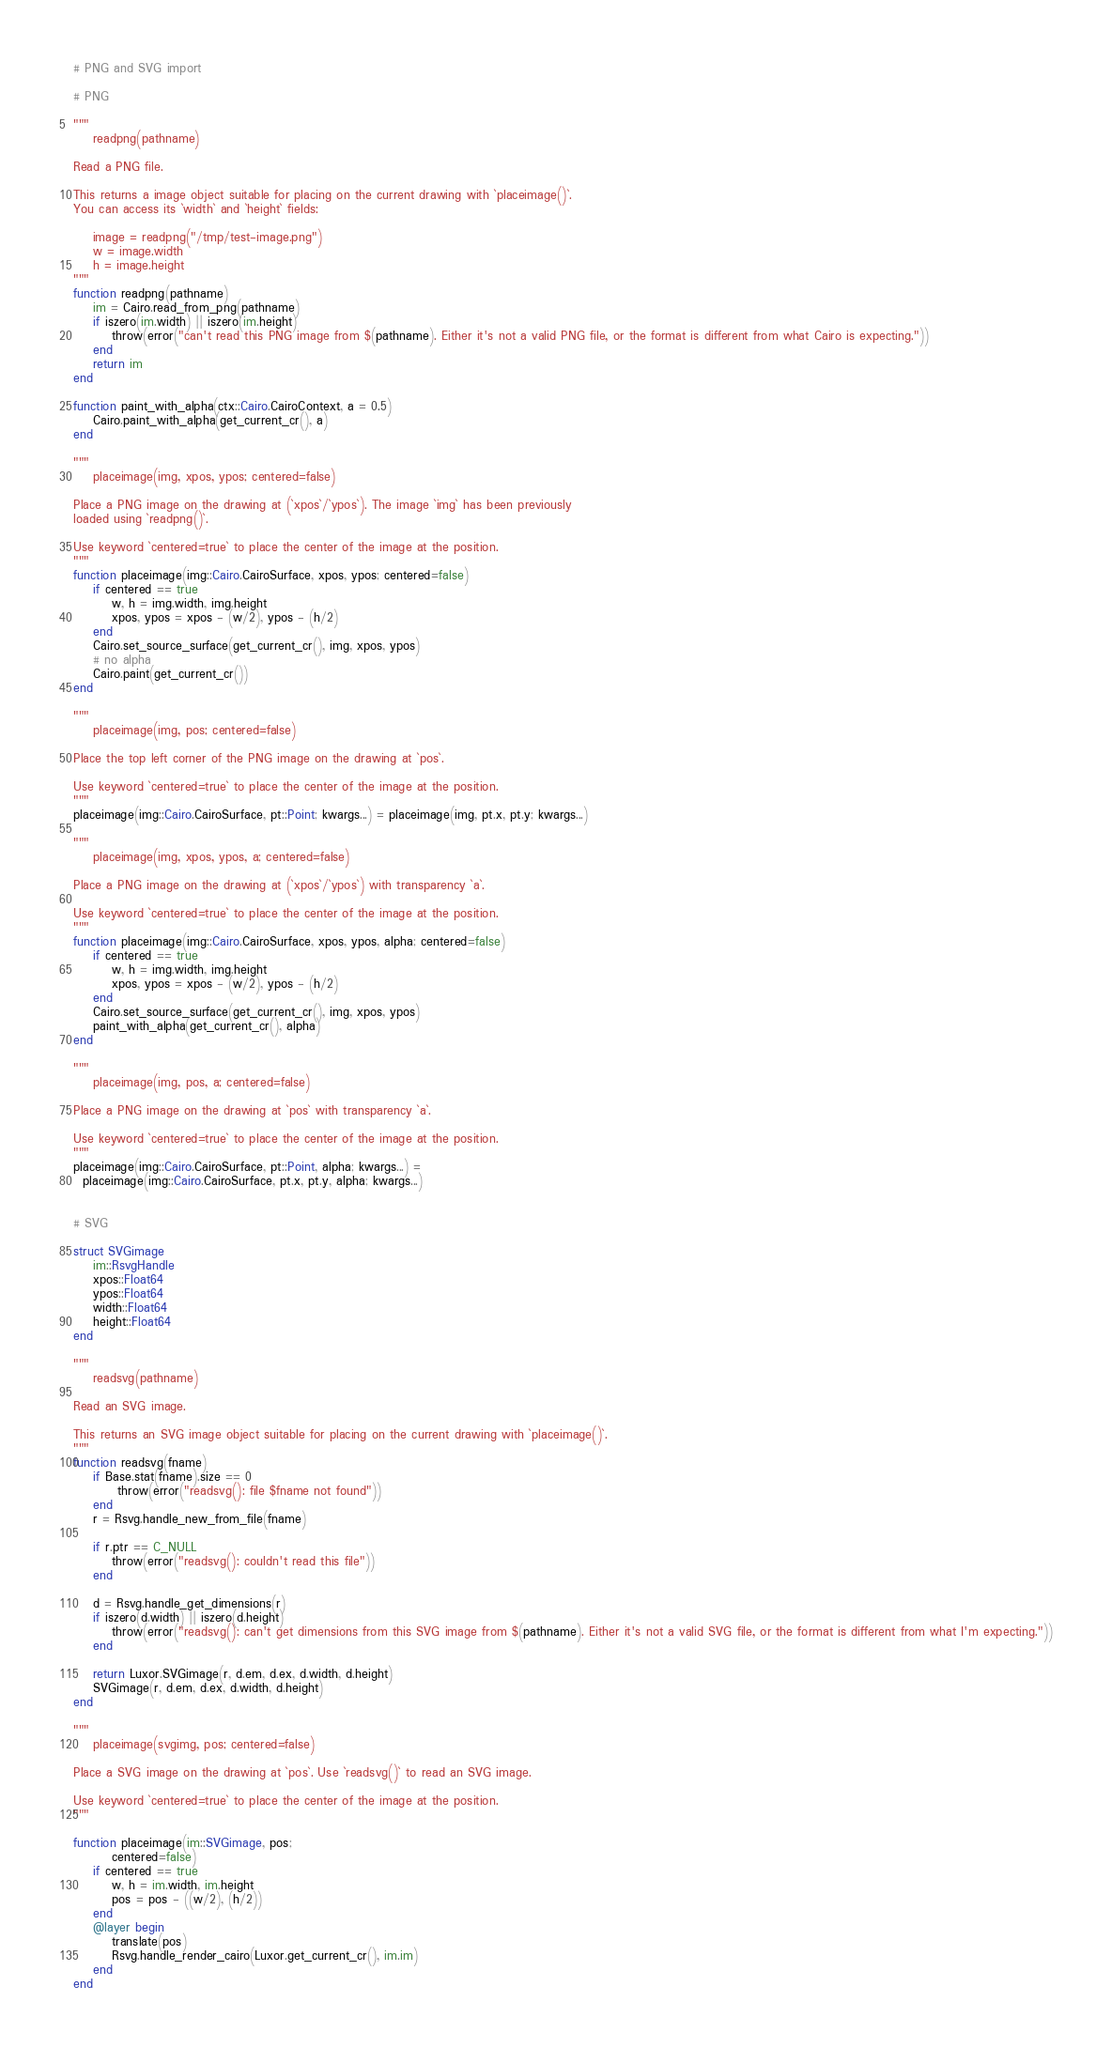Convert code to text. <code><loc_0><loc_0><loc_500><loc_500><_Julia_># PNG and SVG import

# PNG

"""
    readpng(pathname)

Read a PNG file.

This returns a image object suitable for placing on the current drawing with `placeimage()`.
You can access its `width` and `height` fields:

    image = readpng("/tmp/test-image.png")
    w = image.width
    h = image.height
"""
function readpng(pathname)
    im = Cairo.read_from_png(pathname)
    if iszero(im.width) || iszero(im.height)
        throw(error("can't read this PNG image from $(pathname). Either it's not a valid PNG file, or the format is different from what Cairo is expecting."))
    end
    return im
end

function paint_with_alpha(ctx::Cairo.CairoContext, a = 0.5)
    Cairo.paint_with_alpha(get_current_cr(), a)
end

"""
    placeimage(img, xpos, ypos; centered=false)

Place a PNG image on the drawing at (`xpos`/`ypos`). The image `img` has been previously
loaded using `readpng()`.

Use keyword `centered=true` to place the center of the image at the position.
"""
function placeimage(img::Cairo.CairoSurface, xpos, ypos; centered=false)
    if centered == true
        w, h = img.width, img.height
        xpos, ypos = xpos - (w/2), ypos - (h/2)
    end
    Cairo.set_source_surface(get_current_cr(), img, xpos, ypos)
    # no alpha
    Cairo.paint(get_current_cr())
end

"""
    placeimage(img, pos; centered=false)

Place the top left corner of the PNG image on the drawing at `pos`.

Use keyword `centered=true` to place the center of the image at the position.
"""
placeimage(img::Cairo.CairoSurface, pt::Point; kwargs...) = placeimage(img, pt.x, pt.y; kwargs...)

"""
    placeimage(img, xpos, ypos, a; centered=false)

Place a PNG image on the drawing at (`xpos`/`ypos`) with transparency `a`.

Use keyword `centered=true` to place the center of the image at the position.
"""
function placeimage(img::Cairo.CairoSurface, xpos, ypos, alpha; centered=false)
    if centered == true
        w, h = img.width, img.height
        xpos, ypos = xpos - (w/2), ypos - (h/2)
    end
    Cairo.set_source_surface(get_current_cr(), img, xpos, ypos)
    paint_with_alpha(get_current_cr(), alpha)
end

"""
    placeimage(img, pos, a; centered=false)

Place a PNG image on the drawing at `pos` with transparency `a`.

Use keyword `centered=true` to place the center of the image at the position.
"""
placeimage(img::Cairo.CairoSurface, pt::Point, alpha; kwargs...) =
  placeimage(img::Cairo.CairoSurface, pt.x, pt.y, alpha; kwargs...)


# SVG

struct SVGimage
    im::RsvgHandle
    xpos::Float64
    ypos::Float64
    width::Float64
    height::Float64
end

"""
    readsvg(pathname)

Read an SVG image.

This returns an SVG image object suitable for placing on the current drawing with `placeimage()`.
"""
function readsvg(fname)
    if Base.stat(fname).size == 0
         throw(error("readsvg(): file $fname not found"))
    end
    r = Rsvg.handle_new_from_file(fname)

    if r.ptr == C_NULL
        throw(error("readsvg(): couldn't read this file"))
    end

    d = Rsvg.handle_get_dimensions(r)
    if iszero(d.width) || iszero(d.height)
        throw(error("readsvg(): can't get dimensions from this SVG image from $(pathname). Either it's not a valid SVG file, or the format is different from what I'm expecting."))
    end

    return Luxor.SVGimage(r, d.em, d.ex, d.width, d.height)
    SVGimage(r, d.em, d.ex, d.width, d.height)
end

"""
    placeimage(svgimg, pos; centered=false)

Place a SVG image on the drawing at `pos`. Use `readsvg()` to read an SVG image.

Use keyword `centered=true` to place the center of the image at the position.
"""

function placeimage(im::SVGimage, pos;
        centered=false)
    if centered == true
        w, h = im.width, im.height
        pos = pos - ((w/2), (h/2))
    end
    @layer begin
        translate(pos)
        Rsvg.handle_render_cairo(Luxor.get_current_cr(), im.im)
    end
end
</code> 